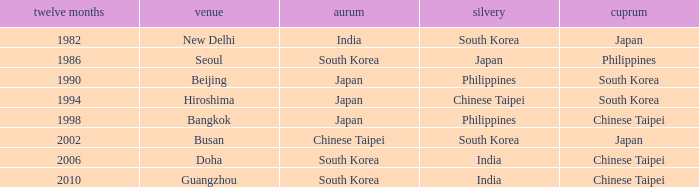Which Year is the highest one that has a Bronze of south korea, and a Silver of philippines? 1990.0. 